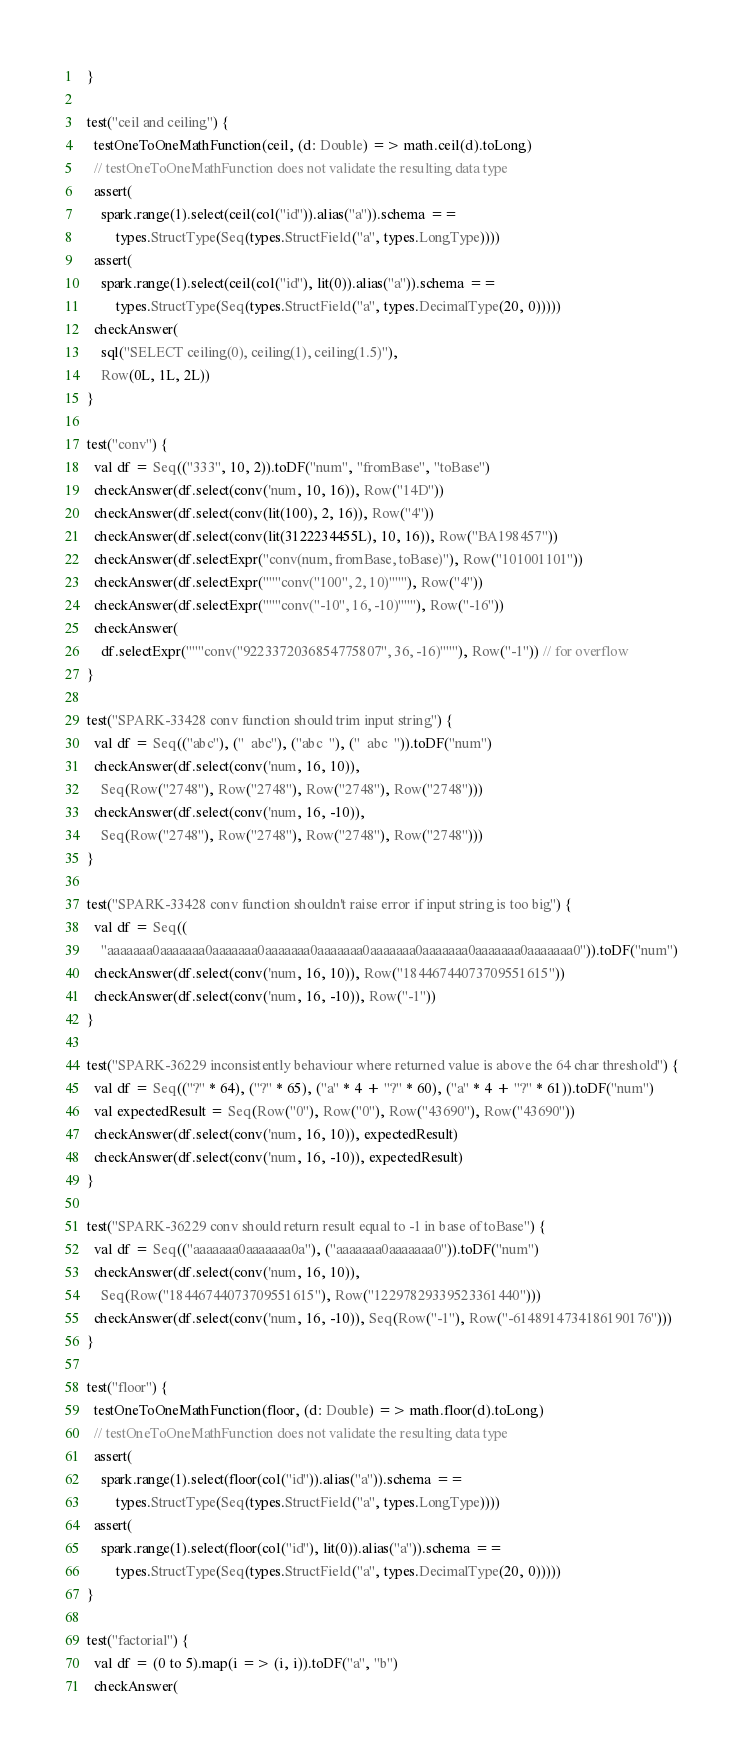<code> <loc_0><loc_0><loc_500><loc_500><_Scala_>  }

  test("ceil and ceiling") {
    testOneToOneMathFunction(ceil, (d: Double) => math.ceil(d).toLong)
    // testOneToOneMathFunction does not validate the resulting data type
    assert(
      spark.range(1).select(ceil(col("id")).alias("a")).schema ==
          types.StructType(Seq(types.StructField("a", types.LongType))))
    assert(
      spark.range(1).select(ceil(col("id"), lit(0)).alias("a")).schema ==
          types.StructType(Seq(types.StructField("a", types.DecimalType(20, 0)))))
    checkAnswer(
      sql("SELECT ceiling(0), ceiling(1), ceiling(1.5)"),
      Row(0L, 1L, 2L))
  }

  test("conv") {
    val df = Seq(("333", 10, 2)).toDF("num", "fromBase", "toBase")
    checkAnswer(df.select(conv('num, 10, 16)), Row("14D"))
    checkAnswer(df.select(conv(lit(100), 2, 16)), Row("4"))
    checkAnswer(df.select(conv(lit(3122234455L), 10, 16)), Row("BA198457"))
    checkAnswer(df.selectExpr("conv(num, fromBase, toBase)"), Row("101001101"))
    checkAnswer(df.selectExpr("""conv("100", 2, 10)"""), Row("4"))
    checkAnswer(df.selectExpr("""conv("-10", 16, -10)"""), Row("-16"))
    checkAnswer(
      df.selectExpr("""conv("9223372036854775807", 36, -16)"""), Row("-1")) // for overflow
  }

  test("SPARK-33428 conv function should trim input string") {
    val df = Seq(("abc"), ("  abc"), ("abc  "), ("  abc  ")).toDF("num")
    checkAnswer(df.select(conv('num, 16, 10)),
      Seq(Row("2748"), Row("2748"), Row("2748"), Row("2748")))
    checkAnswer(df.select(conv('num, 16, -10)),
      Seq(Row("2748"), Row("2748"), Row("2748"), Row("2748")))
  }

  test("SPARK-33428 conv function shouldn't raise error if input string is too big") {
    val df = Seq((
      "aaaaaaa0aaaaaaa0aaaaaaa0aaaaaaa0aaaaaaa0aaaaaaa0aaaaaaa0aaaaaaa0aaaaaaa0")).toDF("num")
    checkAnswer(df.select(conv('num, 16, 10)), Row("18446744073709551615"))
    checkAnswer(df.select(conv('num, 16, -10)), Row("-1"))
  }

  test("SPARK-36229 inconsistently behaviour where returned value is above the 64 char threshold") {
    val df = Seq(("?" * 64), ("?" * 65), ("a" * 4 + "?" * 60), ("a" * 4 + "?" * 61)).toDF("num")
    val expectedResult = Seq(Row("0"), Row("0"), Row("43690"), Row("43690"))
    checkAnswer(df.select(conv('num, 16, 10)), expectedResult)
    checkAnswer(df.select(conv('num, 16, -10)), expectedResult)
  }

  test("SPARK-36229 conv should return result equal to -1 in base of toBase") {
    val df = Seq(("aaaaaaa0aaaaaaa0a"), ("aaaaaaa0aaaaaaa0")).toDF("num")
    checkAnswer(df.select(conv('num, 16, 10)),
      Seq(Row("18446744073709551615"), Row("12297829339523361440")))
    checkAnswer(df.select(conv('num, 16, -10)), Seq(Row("-1"), Row("-6148914734186190176")))
  }

  test("floor") {
    testOneToOneMathFunction(floor, (d: Double) => math.floor(d).toLong)
    // testOneToOneMathFunction does not validate the resulting data type
    assert(
      spark.range(1).select(floor(col("id")).alias("a")).schema ==
          types.StructType(Seq(types.StructField("a", types.LongType))))
    assert(
      spark.range(1).select(floor(col("id"), lit(0)).alias("a")).schema ==
          types.StructType(Seq(types.StructField("a", types.DecimalType(20, 0)))))
  }

  test("factorial") {
    val df = (0 to 5).map(i => (i, i)).toDF("a", "b")
    checkAnswer(</code> 